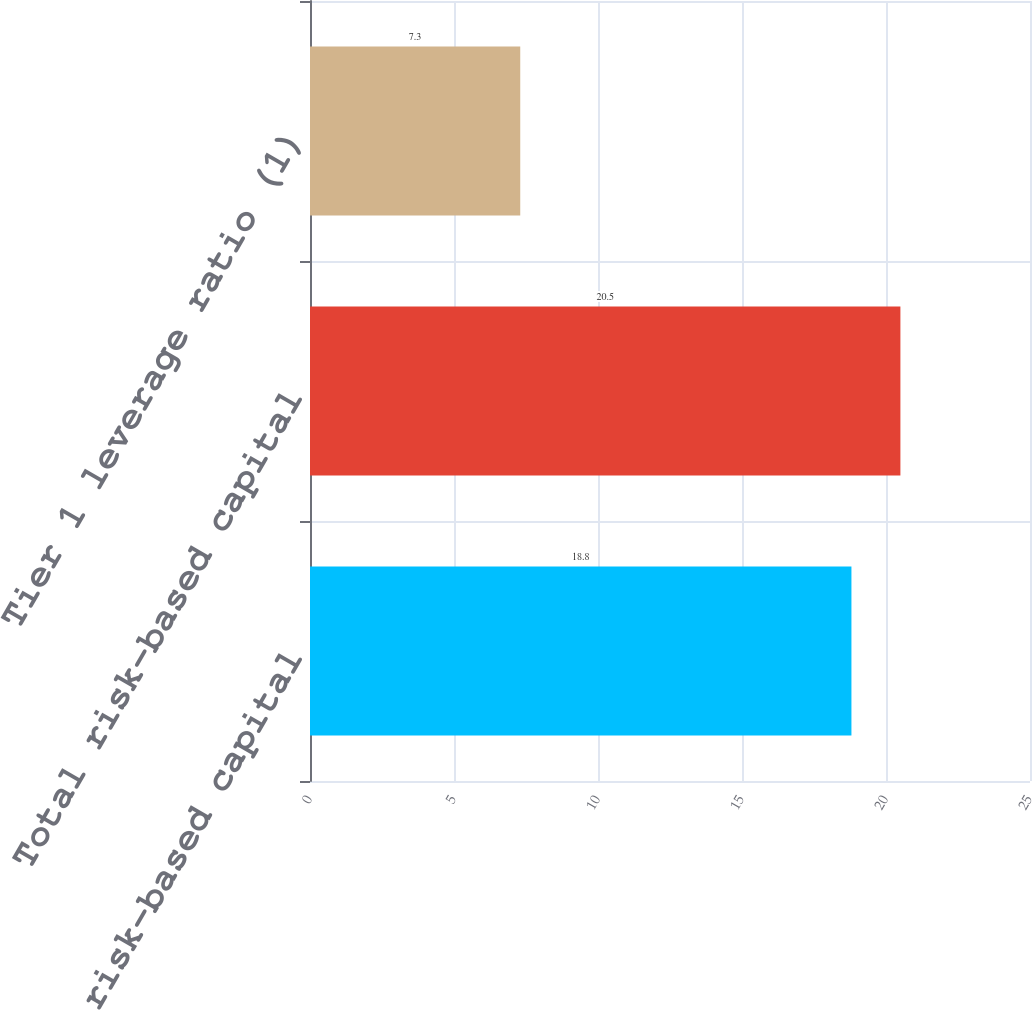Convert chart. <chart><loc_0><loc_0><loc_500><loc_500><bar_chart><fcel>Tier 1 risk-based capital<fcel>Total risk-based capital<fcel>Tier 1 leverage ratio (1)<nl><fcel>18.8<fcel>20.5<fcel>7.3<nl></chart> 